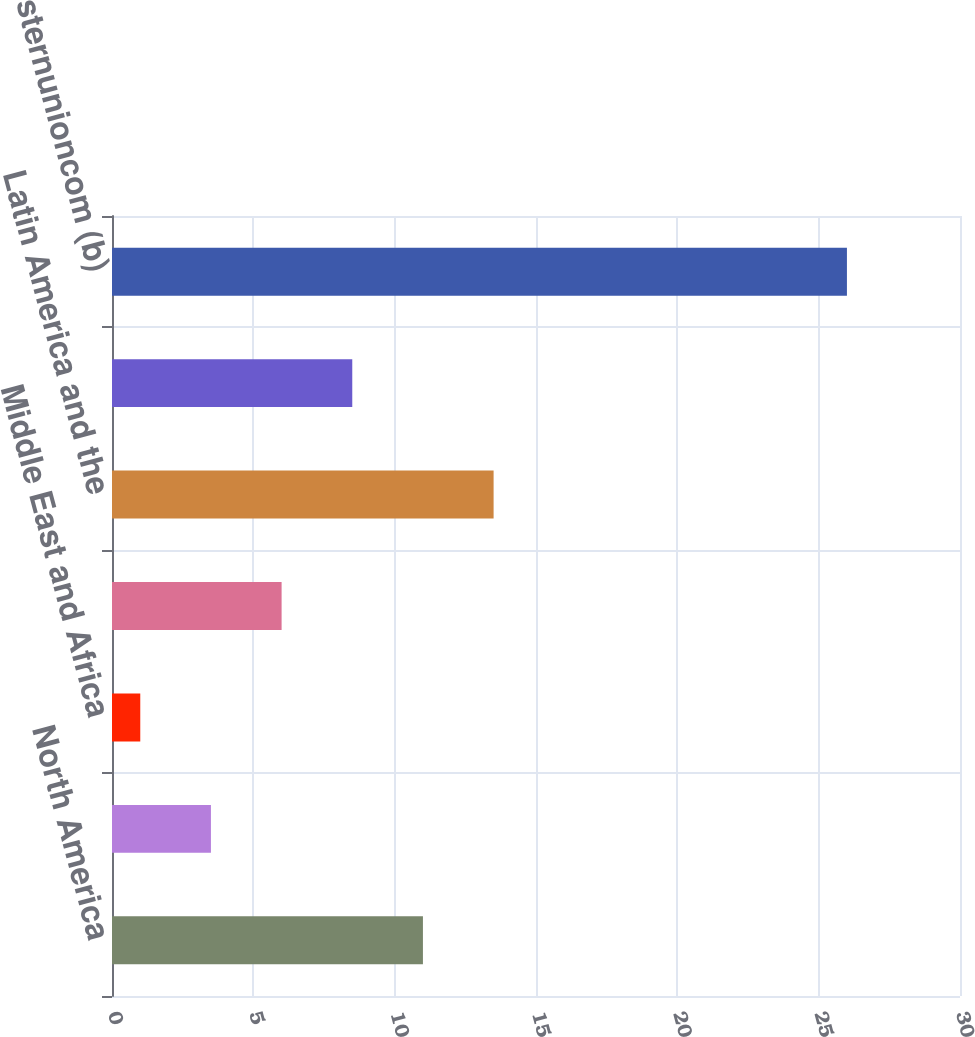Convert chart. <chart><loc_0><loc_0><loc_500><loc_500><bar_chart><fcel>North America<fcel>Europe and CIS<fcel>Middle East and Africa<fcel>Asia Pacific (APAC)<fcel>Latin America and the<fcel>Total Consumer-to-Consumer<fcel>westernunioncom (b)<nl><fcel>11<fcel>3.5<fcel>1<fcel>6<fcel>13.5<fcel>8.5<fcel>26<nl></chart> 